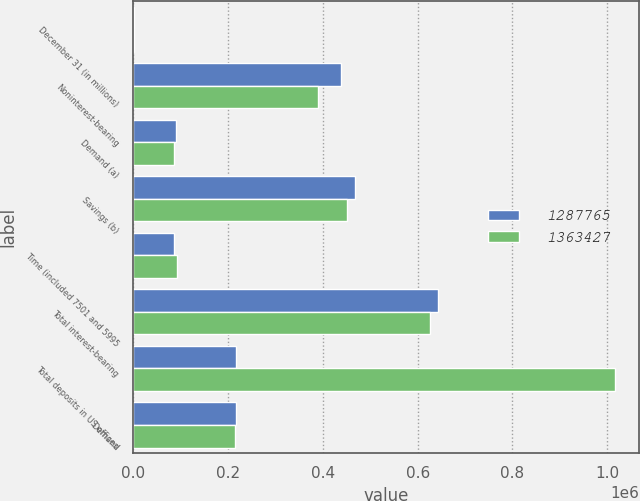Convert chart to OTSL. <chart><loc_0><loc_0><loc_500><loc_500><stacked_bar_chart><ecel><fcel>December 31 (in millions)<fcel>Noninterest-bearing<fcel>Demand (a)<fcel>Savings (b)<fcel>Time (included 7501 and 5995<fcel>Total interest-bearing<fcel>Total deposits in US offices<fcel>Demand<nl><fcel>1.28776e+06<fcel>2014<fcel>437558<fcel>90319<fcel>466730<fcel>86301<fcel>643350<fcel>217011<fcel>217011<nl><fcel>1.36343e+06<fcel>2013<fcel>389863<fcel>84631<fcel>450405<fcel>91356<fcel>626392<fcel>1.01626e+06<fcel>214391<nl></chart> 